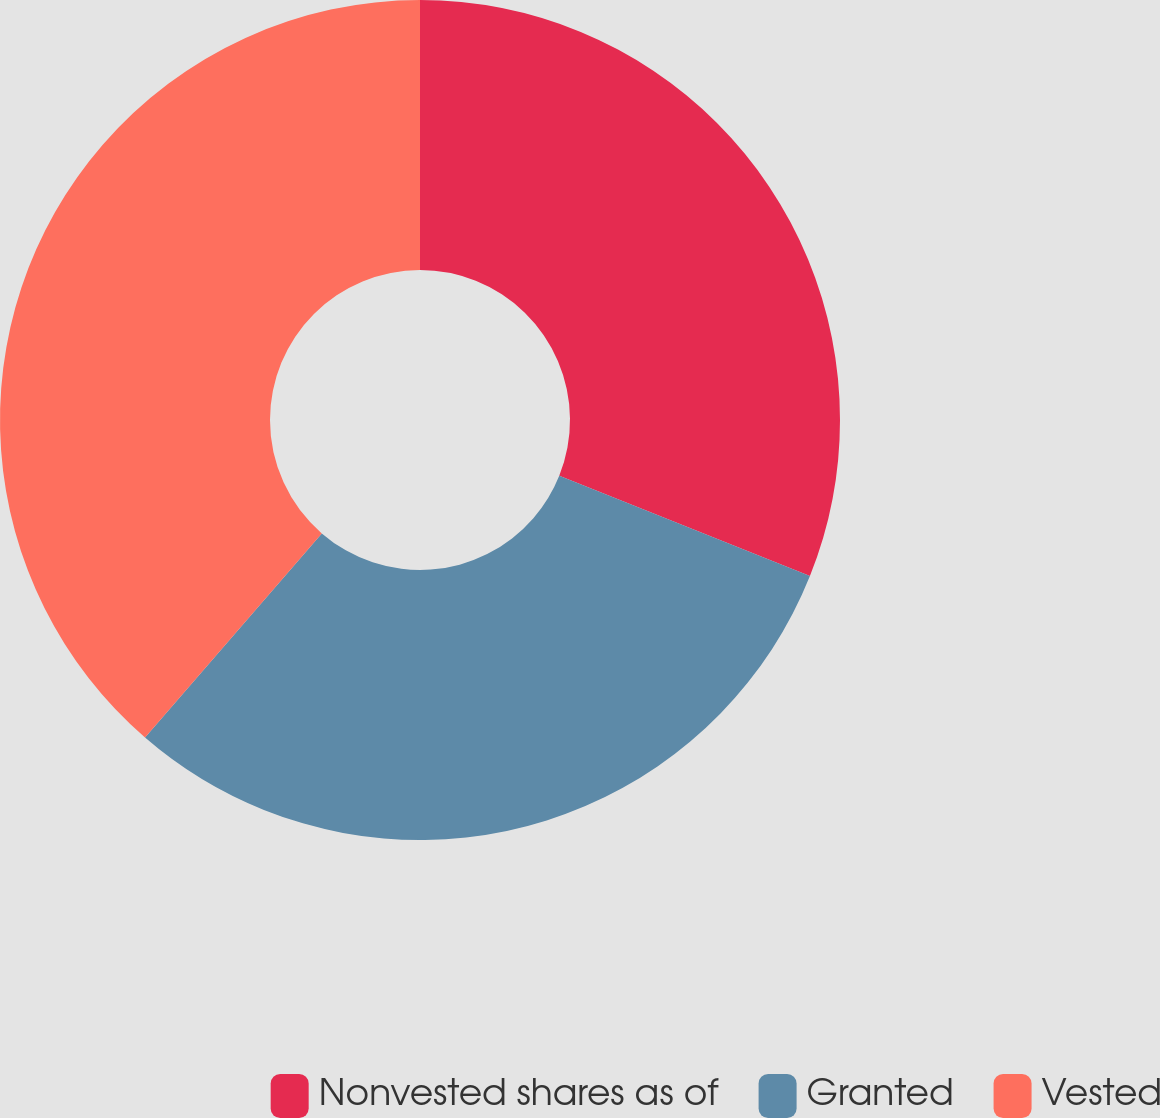Convert chart. <chart><loc_0><loc_0><loc_500><loc_500><pie_chart><fcel>Nonvested shares as of<fcel>Granted<fcel>Vested<nl><fcel>31.06%<fcel>30.3%<fcel>38.64%<nl></chart> 